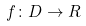Convert formula to latex. <formula><loc_0><loc_0><loc_500><loc_500>f \colon D \rightarrow R</formula> 